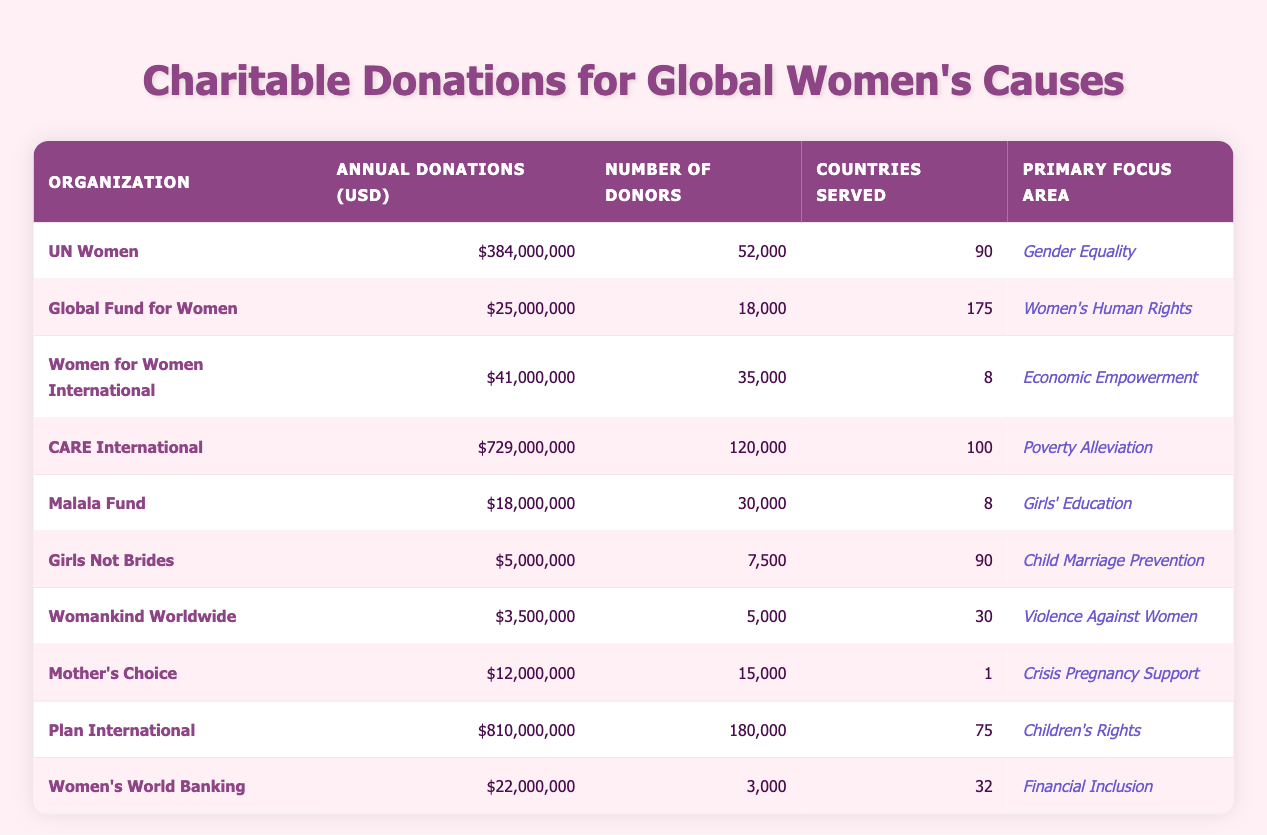What's the organization with the highest annual donations? By looking at the "Annual Donations (USD)" column, CARE International has the highest annual donations at $729,000,000.
Answer: CARE International How many countries does the Global Fund for Women serve? The "Countries Served" column indicates that the Global Fund for Women serves 175 countries.
Answer: 175 What is the total annual donations of all the organizations listed? To find the total, sum the annual donations: 384,000,000 + 25,000,000 + 41,000,000 + 729,000,000 + 18,000,000 + 5,000,000 + 3,500,000 + 12,000,000 + 810,000,000 + 22,000,000 = 2,200,500,000.
Answer: 2,200,500,000 Does Womankind Worldwide have more donors than Mother's Choice? Womankind Worldwide has 5,000 donors and Mother's Choice has 15,000 donors. Therefore, Womankind Worldwide does not have more donors than Mother's Choice.
Answer: No What is the average number of donors across all organizations? Add all donors: 52,000 + 18,000 + 35,000 + 120,000 + 30,000 + 7,500 + 5,000 + 15,000 + 180,000 + 3,000 = 410,500. There are 10 organizations, so the average is 410,500 / 10 = 41,050.
Answer: 41,050 Which organization serves the least number of countries? The "Countries Served" column shows that Mother's Choice serves only 1 country, which is the least among all organizations listed.
Answer: Mother's Choice Is the total number of donors for Plan International greater than the total for UN Women and Women for Women International combined? Plan International has 180,000 donors while UN Women has 52,000 and Women for Women International has 35,000. The combined total of the latter two is 52,000 + 35,000 = 87,000. Since 180,000 is greater than 87,000, the statement is true.
Answer: Yes What is the difference in annual donations between CARE International and the Global Fund for Women? CARE International has annual donations of $729,000,000 and the Global Fund for Women has $25,000,000. To find the difference, subtract: 729,000,000 - 25,000,000 = 704,000,000.
Answer: 704,000,000 Which organization focuses on girls' education and how much do they receive in donations? The organization that focuses on girls' education is Malala Fund, which receives $18,000,000 in annual donations.
Answer: Malala Fund, $18,000,000 